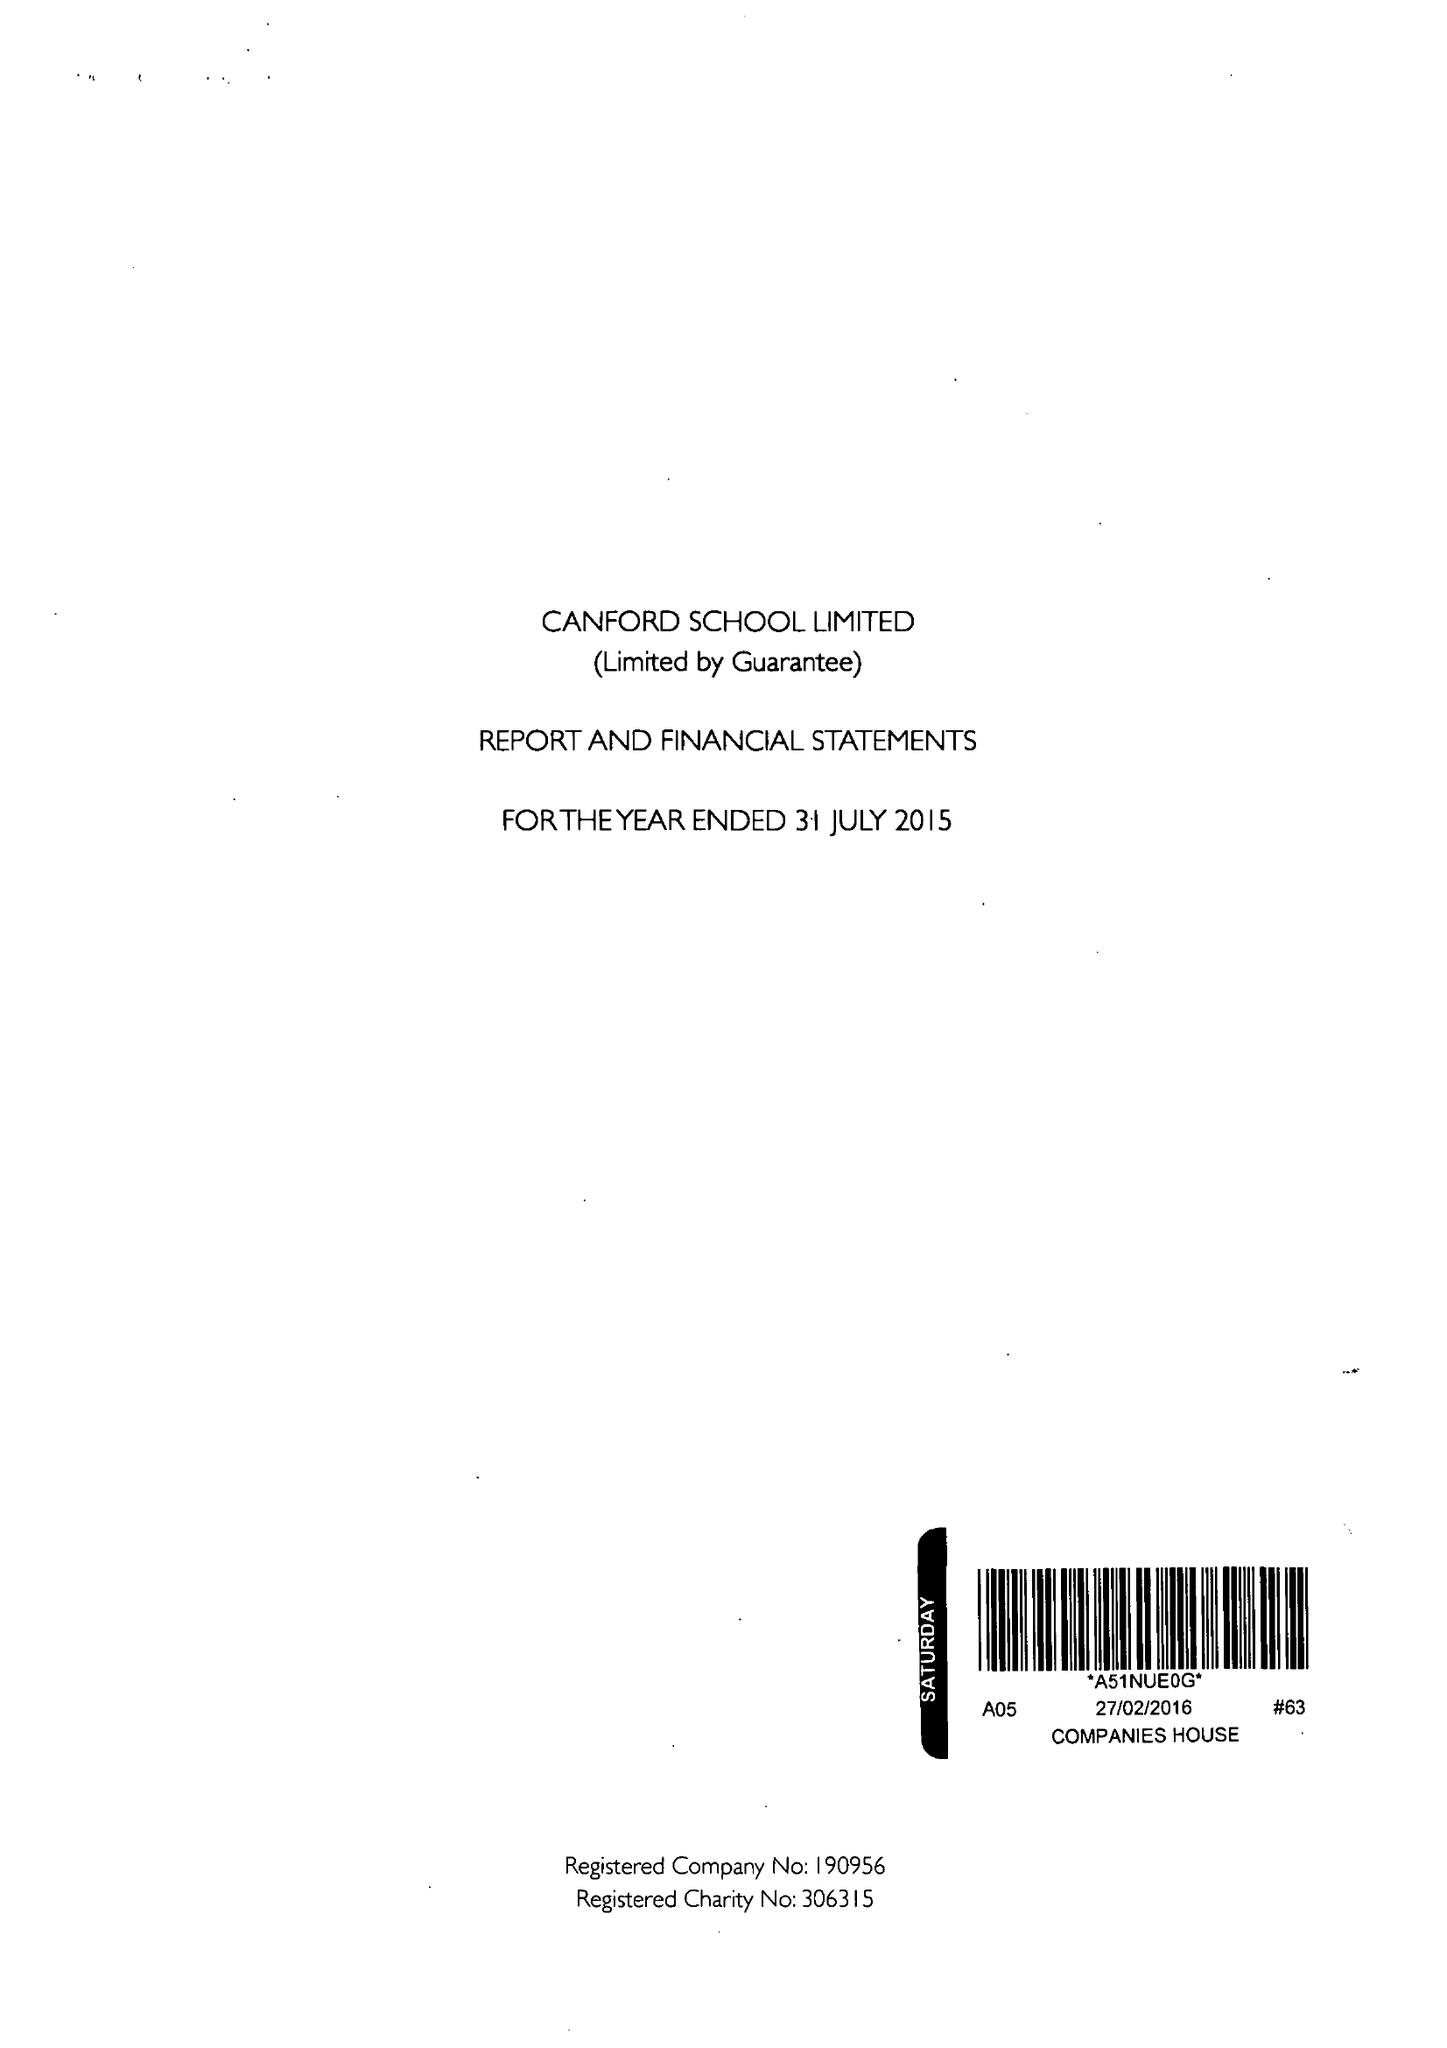What is the value for the report_date?
Answer the question using a single word or phrase. 2015-07-31 